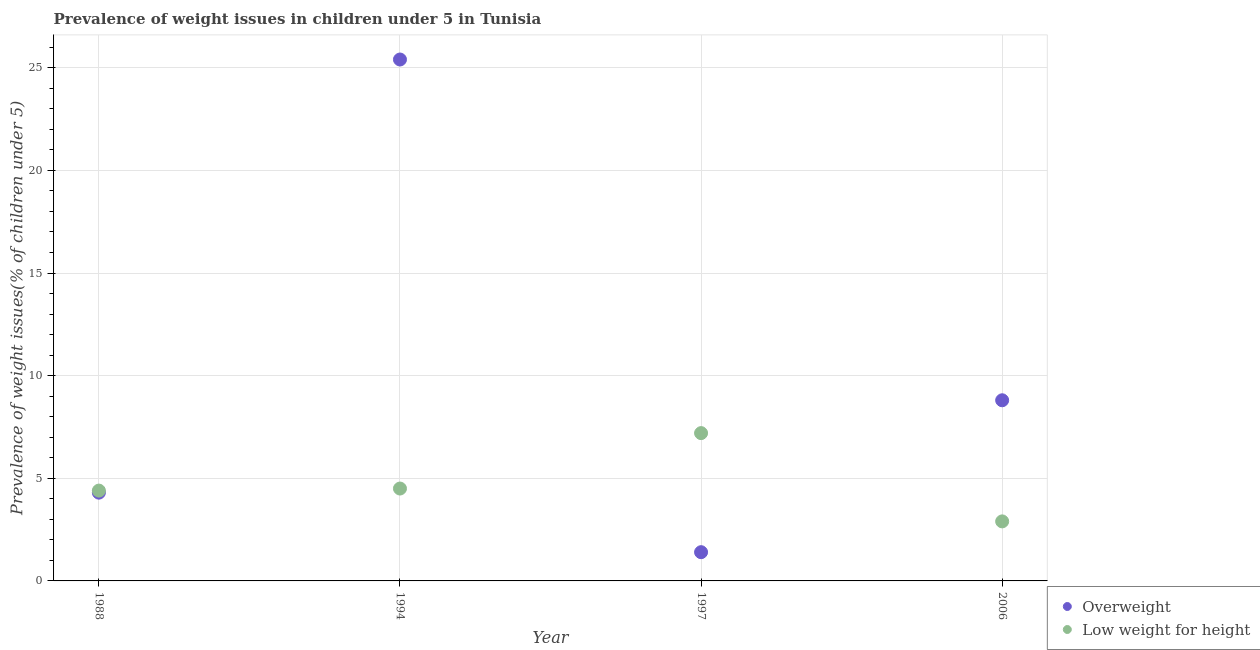Is the number of dotlines equal to the number of legend labels?
Give a very brief answer. Yes. What is the percentage of underweight children in 1994?
Provide a succinct answer. 4.5. Across all years, what is the maximum percentage of underweight children?
Your response must be concise. 7.2. Across all years, what is the minimum percentage of overweight children?
Offer a terse response. 1.4. What is the total percentage of underweight children in the graph?
Your answer should be compact. 19. What is the difference between the percentage of underweight children in 1988 and that in 1994?
Offer a very short reply. -0.1. What is the difference between the percentage of overweight children in 2006 and the percentage of underweight children in 1988?
Your answer should be very brief. 4.4. What is the average percentage of underweight children per year?
Provide a short and direct response. 4.75. In the year 1997, what is the difference between the percentage of underweight children and percentage of overweight children?
Give a very brief answer. 5.8. In how many years, is the percentage of underweight children greater than 23 %?
Keep it short and to the point. 0. What is the ratio of the percentage of overweight children in 1997 to that in 2006?
Your response must be concise. 0.16. Is the percentage of overweight children in 1988 less than that in 1994?
Your answer should be very brief. Yes. Is the difference between the percentage of overweight children in 1994 and 2006 greater than the difference between the percentage of underweight children in 1994 and 2006?
Provide a short and direct response. Yes. What is the difference between the highest and the second highest percentage of overweight children?
Keep it short and to the point. 16.6. What is the difference between the highest and the lowest percentage of underweight children?
Your answer should be compact. 4.3. In how many years, is the percentage of overweight children greater than the average percentage of overweight children taken over all years?
Make the answer very short. 1. Is the sum of the percentage of underweight children in 1994 and 1997 greater than the maximum percentage of overweight children across all years?
Your answer should be very brief. No. Does the percentage of underweight children monotonically increase over the years?
Provide a short and direct response. No. Is the percentage of overweight children strictly less than the percentage of underweight children over the years?
Keep it short and to the point. No. How many years are there in the graph?
Provide a succinct answer. 4. What is the difference between two consecutive major ticks on the Y-axis?
Your answer should be very brief. 5. Are the values on the major ticks of Y-axis written in scientific E-notation?
Ensure brevity in your answer.  No. Where does the legend appear in the graph?
Offer a terse response. Bottom right. How many legend labels are there?
Make the answer very short. 2. What is the title of the graph?
Keep it short and to the point. Prevalence of weight issues in children under 5 in Tunisia. What is the label or title of the X-axis?
Give a very brief answer. Year. What is the label or title of the Y-axis?
Ensure brevity in your answer.  Prevalence of weight issues(% of children under 5). What is the Prevalence of weight issues(% of children under 5) in Overweight in 1988?
Offer a terse response. 4.3. What is the Prevalence of weight issues(% of children under 5) of Low weight for height in 1988?
Give a very brief answer. 4.4. What is the Prevalence of weight issues(% of children under 5) in Overweight in 1994?
Keep it short and to the point. 25.4. What is the Prevalence of weight issues(% of children under 5) of Overweight in 1997?
Offer a very short reply. 1.4. What is the Prevalence of weight issues(% of children under 5) in Low weight for height in 1997?
Your answer should be compact. 7.2. What is the Prevalence of weight issues(% of children under 5) in Overweight in 2006?
Give a very brief answer. 8.8. What is the Prevalence of weight issues(% of children under 5) in Low weight for height in 2006?
Your response must be concise. 2.9. Across all years, what is the maximum Prevalence of weight issues(% of children under 5) in Overweight?
Your response must be concise. 25.4. Across all years, what is the maximum Prevalence of weight issues(% of children under 5) of Low weight for height?
Provide a succinct answer. 7.2. Across all years, what is the minimum Prevalence of weight issues(% of children under 5) of Overweight?
Keep it short and to the point. 1.4. Across all years, what is the minimum Prevalence of weight issues(% of children under 5) of Low weight for height?
Provide a succinct answer. 2.9. What is the total Prevalence of weight issues(% of children under 5) in Overweight in the graph?
Ensure brevity in your answer.  39.9. What is the difference between the Prevalence of weight issues(% of children under 5) of Overweight in 1988 and that in 1994?
Provide a short and direct response. -21.1. What is the difference between the Prevalence of weight issues(% of children under 5) in Low weight for height in 1988 and that in 1997?
Give a very brief answer. -2.8. What is the difference between the Prevalence of weight issues(% of children under 5) of Overweight in 1988 and that in 2006?
Make the answer very short. -4.5. What is the difference between the Prevalence of weight issues(% of children under 5) of Overweight in 1994 and that in 1997?
Provide a short and direct response. 24. What is the difference between the Prevalence of weight issues(% of children under 5) of Overweight in 1994 and that in 2006?
Your response must be concise. 16.6. What is the difference between the Prevalence of weight issues(% of children under 5) in Low weight for height in 1994 and that in 2006?
Ensure brevity in your answer.  1.6. What is the average Prevalence of weight issues(% of children under 5) of Overweight per year?
Your answer should be very brief. 9.97. What is the average Prevalence of weight issues(% of children under 5) in Low weight for height per year?
Give a very brief answer. 4.75. In the year 1994, what is the difference between the Prevalence of weight issues(% of children under 5) of Overweight and Prevalence of weight issues(% of children under 5) of Low weight for height?
Provide a short and direct response. 20.9. In the year 2006, what is the difference between the Prevalence of weight issues(% of children under 5) of Overweight and Prevalence of weight issues(% of children under 5) of Low weight for height?
Provide a succinct answer. 5.9. What is the ratio of the Prevalence of weight issues(% of children under 5) in Overweight in 1988 to that in 1994?
Your answer should be compact. 0.17. What is the ratio of the Prevalence of weight issues(% of children under 5) of Low weight for height in 1988 to that in 1994?
Keep it short and to the point. 0.98. What is the ratio of the Prevalence of weight issues(% of children under 5) of Overweight in 1988 to that in 1997?
Provide a short and direct response. 3.07. What is the ratio of the Prevalence of weight issues(% of children under 5) in Low weight for height in 1988 to that in 1997?
Ensure brevity in your answer.  0.61. What is the ratio of the Prevalence of weight issues(% of children under 5) of Overweight in 1988 to that in 2006?
Ensure brevity in your answer.  0.49. What is the ratio of the Prevalence of weight issues(% of children under 5) in Low weight for height in 1988 to that in 2006?
Provide a short and direct response. 1.52. What is the ratio of the Prevalence of weight issues(% of children under 5) of Overweight in 1994 to that in 1997?
Keep it short and to the point. 18.14. What is the ratio of the Prevalence of weight issues(% of children under 5) of Low weight for height in 1994 to that in 1997?
Offer a very short reply. 0.62. What is the ratio of the Prevalence of weight issues(% of children under 5) of Overweight in 1994 to that in 2006?
Give a very brief answer. 2.89. What is the ratio of the Prevalence of weight issues(% of children under 5) of Low weight for height in 1994 to that in 2006?
Offer a terse response. 1.55. What is the ratio of the Prevalence of weight issues(% of children under 5) of Overweight in 1997 to that in 2006?
Your answer should be compact. 0.16. What is the ratio of the Prevalence of weight issues(% of children under 5) of Low weight for height in 1997 to that in 2006?
Provide a succinct answer. 2.48. What is the difference between the highest and the second highest Prevalence of weight issues(% of children under 5) of Low weight for height?
Give a very brief answer. 2.7. What is the difference between the highest and the lowest Prevalence of weight issues(% of children under 5) in Overweight?
Give a very brief answer. 24. What is the difference between the highest and the lowest Prevalence of weight issues(% of children under 5) in Low weight for height?
Offer a very short reply. 4.3. 